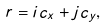<formula> <loc_0><loc_0><loc_500><loc_500>r = i c _ { x } + j c _ { y } ,</formula> 